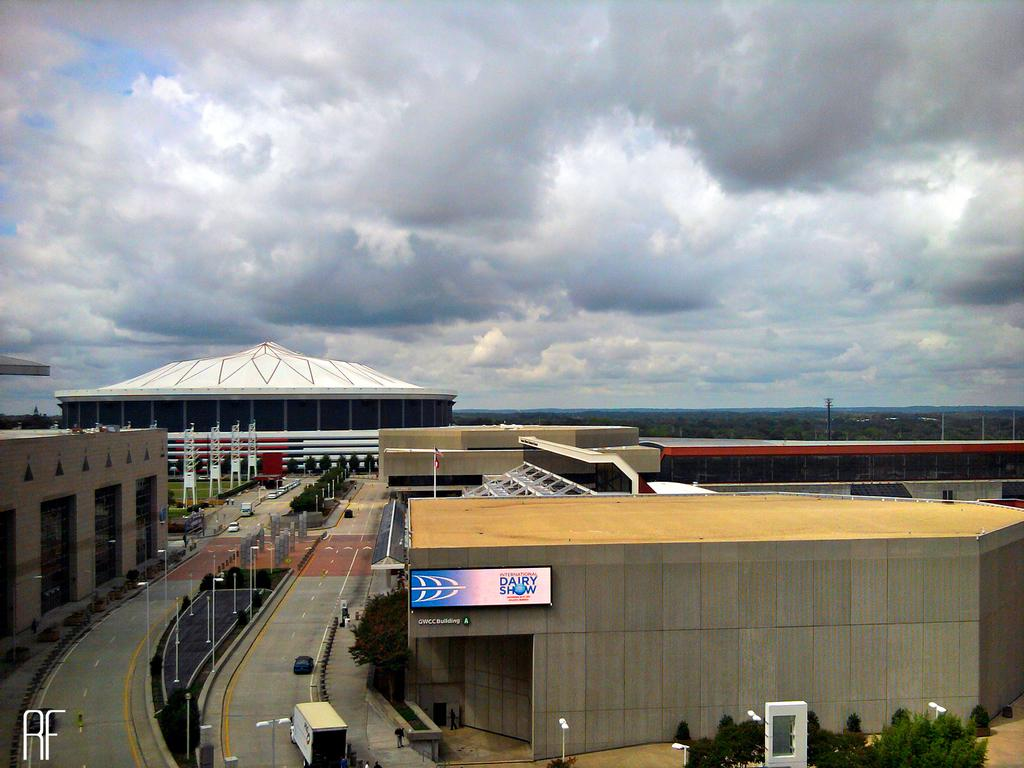What can be seen in the sky in the image? The sky with clouds is visible in the image. What type of vegetation is present in the image? There are trees, shrubs, and bushes visible in the image. What structures are present in the image? Towers, buildings, and iron grills are present in the image. What type of lighting is visible in the image? Street lights are present in the image. What type of poles can be seen in the image? Poles and street poles are visible in the image. What type of transportation is present in the image? Motor vehicles are present in the image. What type of signage is visible in the image? Information boards are visible in the image. What type of linen is draped over the cannon in the image? There is no cannon or linen present in the image. What type of pollution is visible in the image? There is no visible pollution in the image. 